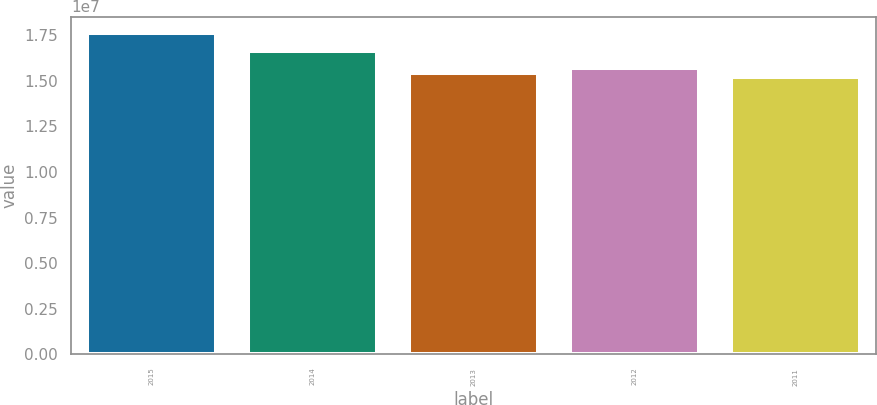Convert chart. <chart><loc_0><loc_0><loc_500><loc_500><bar_chart><fcel>2015<fcel>2014<fcel>2013<fcel>2012<fcel>2011<nl><fcel>1.7627e+07<fcel>1.6622e+07<fcel>1.54346e+07<fcel>1.56782e+07<fcel>1.5191e+07<nl></chart> 